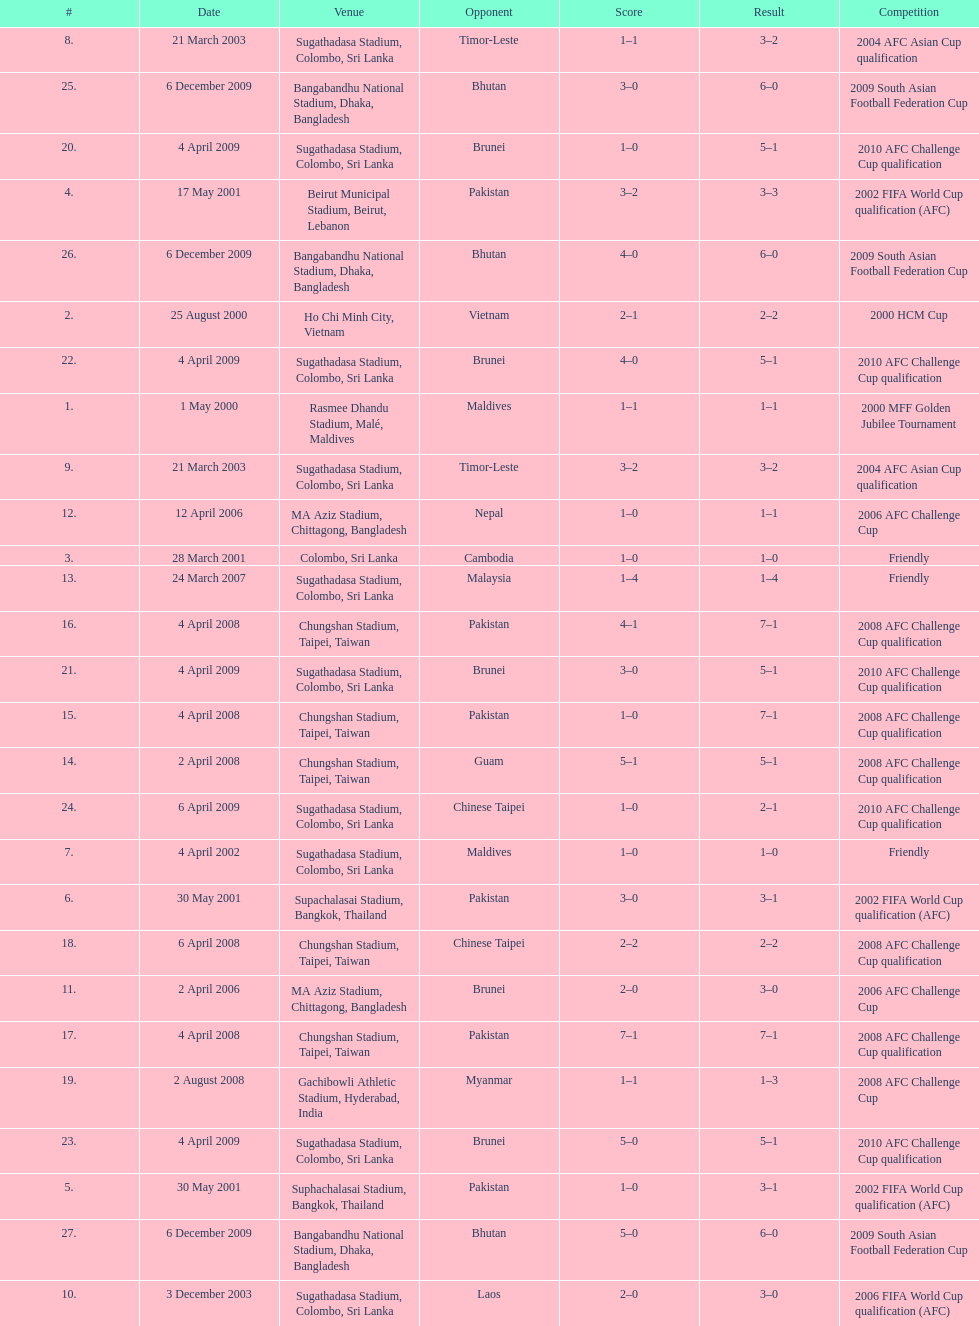What was the total number of goals score in the sri lanka - malaysia game of march 24, 2007? 5. 